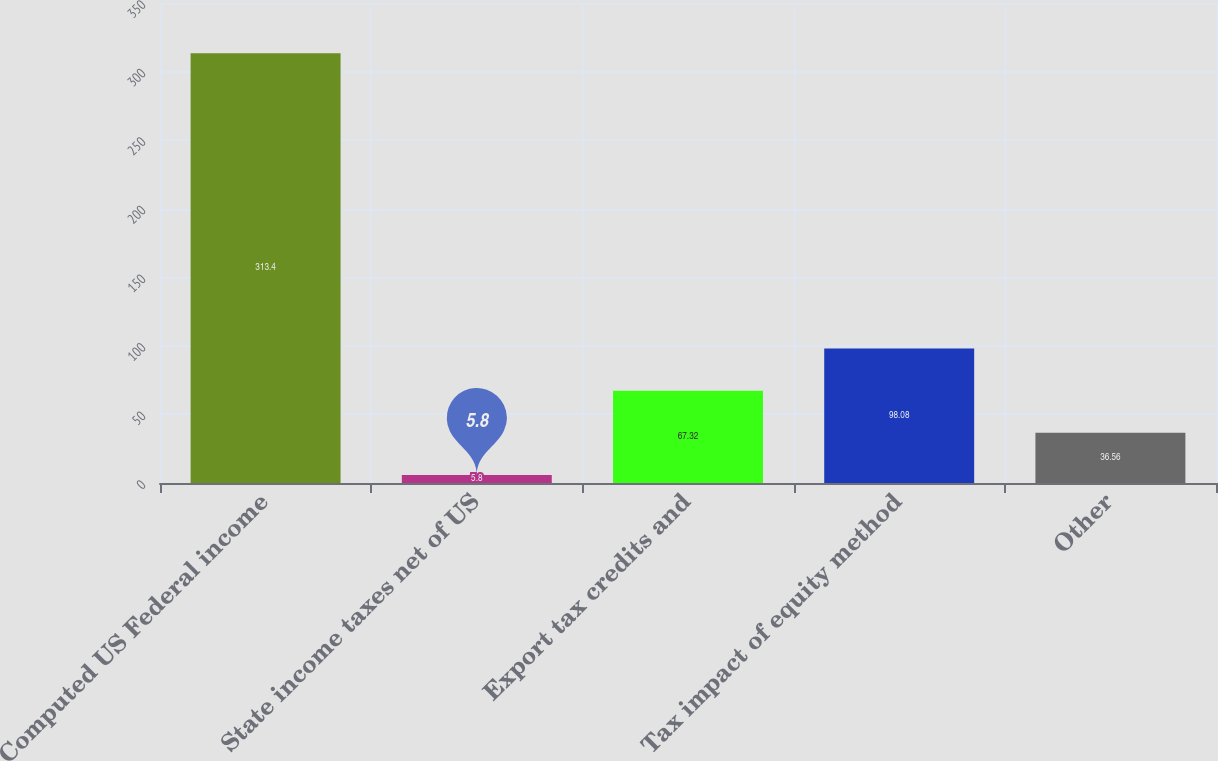Convert chart. <chart><loc_0><loc_0><loc_500><loc_500><bar_chart><fcel>Computed US Federal income<fcel>State income taxes net of US<fcel>Export tax credits and<fcel>Tax impact of equity method<fcel>Other<nl><fcel>313.4<fcel>5.8<fcel>67.32<fcel>98.08<fcel>36.56<nl></chart> 